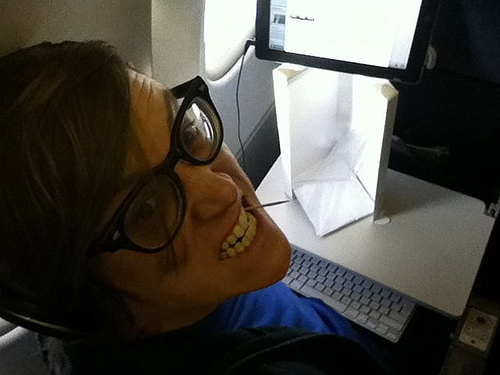What is common to the wire and the glass? The wire and the glass share a common characteristic: their color. 